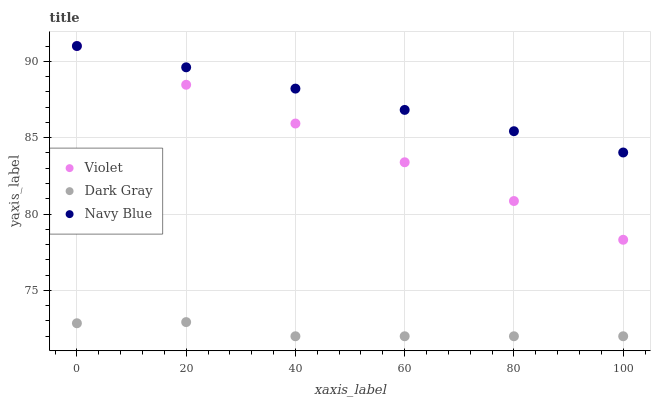Does Dark Gray have the minimum area under the curve?
Answer yes or no. Yes. Does Navy Blue have the maximum area under the curve?
Answer yes or no. Yes. Does Violet have the minimum area under the curve?
Answer yes or no. No. Does Violet have the maximum area under the curve?
Answer yes or no. No. Is Navy Blue the smoothest?
Answer yes or no. Yes. Is Dark Gray the roughest?
Answer yes or no. Yes. Is Violet the smoothest?
Answer yes or no. No. Is Violet the roughest?
Answer yes or no. No. Does Dark Gray have the lowest value?
Answer yes or no. Yes. Does Violet have the lowest value?
Answer yes or no. No. Does Violet have the highest value?
Answer yes or no. Yes. Is Dark Gray less than Navy Blue?
Answer yes or no. Yes. Is Navy Blue greater than Dark Gray?
Answer yes or no. Yes. Does Navy Blue intersect Violet?
Answer yes or no. Yes. Is Navy Blue less than Violet?
Answer yes or no. No. Is Navy Blue greater than Violet?
Answer yes or no. No. Does Dark Gray intersect Navy Blue?
Answer yes or no. No. 